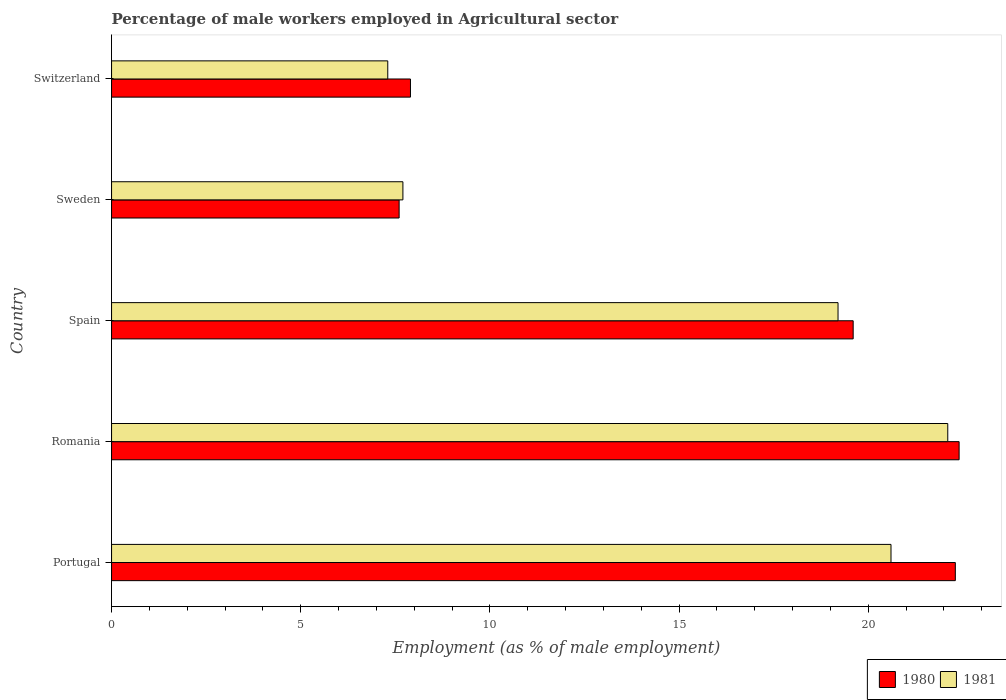How many different coloured bars are there?
Your answer should be compact. 2. How many groups of bars are there?
Provide a short and direct response. 5. Are the number of bars on each tick of the Y-axis equal?
Your answer should be compact. Yes. In how many cases, is the number of bars for a given country not equal to the number of legend labels?
Offer a very short reply. 0. What is the percentage of male workers employed in Agricultural sector in 1980 in Spain?
Provide a short and direct response. 19.6. Across all countries, what is the maximum percentage of male workers employed in Agricultural sector in 1981?
Ensure brevity in your answer.  22.1. Across all countries, what is the minimum percentage of male workers employed in Agricultural sector in 1981?
Keep it short and to the point. 7.3. In which country was the percentage of male workers employed in Agricultural sector in 1980 maximum?
Provide a short and direct response. Romania. In which country was the percentage of male workers employed in Agricultural sector in 1981 minimum?
Your answer should be compact. Switzerland. What is the total percentage of male workers employed in Agricultural sector in 1981 in the graph?
Keep it short and to the point. 76.9. What is the difference between the percentage of male workers employed in Agricultural sector in 1980 in Portugal and that in Spain?
Offer a terse response. 2.7. What is the difference between the percentage of male workers employed in Agricultural sector in 1981 in Spain and the percentage of male workers employed in Agricultural sector in 1980 in Sweden?
Your answer should be compact. 11.6. What is the average percentage of male workers employed in Agricultural sector in 1981 per country?
Offer a terse response. 15.38. What is the difference between the percentage of male workers employed in Agricultural sector in 1980 and percentage of male workers employed in Agricultural sector in 1981 in Sweden?
Your answer should be very brief. -0.1. What is the ratio of the percentage of male workers employed in Agricultural sector in 1981 in Portugal to that in Romania?
Ensure brevity in your answer.  0.93. Is the difference between the percentage of male workers employed in Agricultural sector in 1980 in Portugal and Romania greater than the difference between the percentage of male workers employed in Agricultural sector in 1981 in Portugal and Romania?
Your answer should be very brief. Yes. What is the difference between the highest and the second highest percentage of male workers employed in Agricultural sector in 1981?
Make the answer very short. 1.5. What is the difference between the highest and the lowest percentage of male workers employed in Agricultural sector in 1980?
Your response must be concise. 14.8. Is the sum of the percentage of male workers employed in Agricultural sector in 1980 in Spain and Switzerland greater than the maximum percentage of male workers employed in Agricultural sector in 1981 across all countries?
Provide a succinct answer. Yes. Are all the bars in the graph horizontal?
Offer a terse response. Yes. What is the difference between two consecutive major ticks on the X-axis?
Provide a short and direct response. 5. Are the values on the major ticks of X-axis written in scientific E-notation?
Your answer should be compact. No. What is the title of the graph?
Your response must be concise. Percentage of male workers employed in Agricultural sector. What is the label or title of the X-axis?
Keep it short and to the point. Employment (as % of male employment). What is the Employment (as % of male employment) in 1980 in Portugal?
Give a very brief answer. 22.3. What is the Employment (as % of male employment) in 1981 in Portugal?
Give a very brief answer. 20.6. What is the Employment (as % of male employment) in 1980 in Romania?
Give a very brief answer. 22.4. What is the Employment (as % of male employment) of 1981 in Romania?
Provide a succinct answer. 22.1. What is the Employment (as % of male employment) in 1980 in Spain?
Provide a short and direct response. 19.6. What is the Employment (as % of male employment) in 1981 in Spain?
Give a very brief answer. 19.2. What is the Employment (as % of male employment) of 1980 in Sweden?
Provide a succinct answer. 7.6. What is the Employment (as % of male employment) of 1981 in Sweden?
Your response must be concise. 7.7. What is the Employment (as % of male employment) in 1980 in Switzerland?
Your response must be concise. 7.9. What is the Employment (as % of male employment) in 1981 in Switzerland?
Offer a very short reply. 7.3. Across all countries, what is the maximum Employment (as % of male employment) in 1980?
Give a very brief answer. 22.4. Across all countries, what is the maximum Employment (as % of male employment) of 1981?
Your answer should be compact. 22.1. Across all countries, what is the minimum Employment (as % of male employment) of 1980?
Ensure brevity in your answer.  7.6. Across all countries, what is the minimum Employment (as % of male employment) of 1981?
Offer a terse response. 7.3. What is the total Employment (as % of male employment) in 1980 in the graph?
Offer a very short reply. 79.8. What is the total Employment (as % of male employment) in 1981 in the graph?
Offer a very short reply. 76.9. What is the difference between the Employment (as % of male employment) of 1980 in Portugal and that in Romania?
Ensure brevity in your answer.  -0.1. What is the difference between the Employment (as % of male employment) of 1981 in Portugal and that in Romania?
Your response must be concise. -1.5. What is the difference between the Employment (as % of male employment) in 1981 in Portugal and that in Spain?
Your answer should be compact. 1.4. What is the difference between the Employment (as % of male employment) of 1980 in Romania and that in Switzerland?
Your answer should be compact. 14.5. What is the difference between the Employment (as % of male employment) of 1980 in Spain and that in Sweden?
Provide a short and direct response. 12. What is the difference between the Employment (as % of male employment) in 1981 in Spain and that in Sweden?
Give a very brief answer. 11.5. What is the difference between the Employment (as % of male employment) in 1980 in Spain and that in Switzerland?
Your answer should be very brief. 11.7. What is the difference between the Employment (as % of male employment) of 1980 in Sweden and that in Switzerland?
Provide a short and direct response. -0.3. What is the difference between the Employment (as % of male employment) of 1981 in Sweden and that in Switzerland?
Your answer should be very brief. 0.4. What is the difference between the Employment (as % of male employment) in 1980 in Portugal and the Employment (as % of male employment) in 1981 in Romania?
Offer a very short reply. 0.2. What is the difference between the Employment (as % of male employment) in 1980 in Portugal and the Employment (as % of male employment) in 1981 in Spain?
Your answer should be compact. 3.1. What is the difference between the Employment (as % of male employment) in 1980 in Portugal and the Employment (as % of male employment) in 1981 in Switzerland?
Provide a succinct answer. 15. What is the difference between the Employment (as % of male employment) of 1980 in Romania and the Employment (as % of male employment) of 1981 in Spain?
Ensure brevity in your answer.  3.2. What is the difference between the Employment (as % of male employment) of 1980 in Romania and the Employment (as % of male employment) of 1981 in Sweden?
Offer a very short reply. 14.7. What is the average Employment (as % of male employment) of 1980 per country?
Provide a succinct answer. 15.96. What is the average Employment (as % of male employment) in 1981 per country?
Give a very brief answer. 15.38. What is the difference between the Employment (as % of male employment) in 1980 and Employment (as % of male employment) in 1981 in Romania?
Ensure brevity in your answer.  0.3. What is the difference between the Employment (as % of male employment) of 1980 and Employment (as % of male employment) of 1981 in Sweden?
Keep it short and to the point. -0.1. What is the ratio of the Employment (as % of male employment) in 1981 in Portugal to that in Romania?
Offer a terse response. 0.93. What is the ratio of the Employment (as % of male employment) in 1980 in Portugal to that in Spain?
Offer a very short reply. 1.14. What is the ratio of the Employment (as % of male employment) in 1981 in Portugal to that in Spain?
Offer a very short reply. 1.07. What is the ratio of the Employment (as % of male employment) in 1980 in Portugal to that in Sweden?
Your response must be concise. 2.93. What is the ratio of the Employment (as % of male employment) in 1981 in Portugal to that in Sweden?
Give a very brief answer. 2.68. What is the ratio of the Employment (as % of male employment) in 1980 in Portugal to that in Switzerland?
Keep it short and to the point. 2.82. What is the ratio of the Employment (as % of male employment) in 1981 in Portugal to that in Switzerland?
Ensure brevity in your answer.  2.82. What is the ratio of the Employment (as % of male employment) of 1980 in Romania to that in Spain?
Your response must be concise. 1.14. What is the ratio of the Employment (as % of male employment) in 1981 in Romania to that in Spain?
Make the answer very short. 1.15. What is the ratio of the Employment (as % of male employment) of 1980 in Romania to that in Sweden?
Your answer should be compact. 2.95. What is the ratio of the Employment (as % of male employment) in 1981 in Romania to that in Sweden?
Provide a short and direct response. 2.87. What is the ratio of the Employment (as % of male employment) in 1980 in Romania to that in Switzerland?
Give a very brief answer. 2.84. What is the ratio of the Employment (as % of male employment) of 1981 in Romania to that in Switzerland?
Give a very brief answer. 3.03. What is the ratio of the Employment (as % of male employment) in 1980 in Spain to that in Sweden?
Give a very brief answer. 2.58. What is the ratio of the Employment (as % of male employment) in 1981 in Spain to that in Sweden?
Give a very brief answer. 2.49. What is the ratio of the Employment (as % of male employment) in 1980 in Spain to that in Switzerland?
Offer a very short reply. 2.48. What is the ratio of the Employment (as % of male employment) in 1981 in Spain to that in Switzerland?
Keep it short and to the point. 2.63. What is the ratio of the Employment (as % of male employment) in 1981 in Sweden to that in Switzerland?
Offer a terse response. 1.05. What is the difference between the highest and the second highest Employment (as % of male employment) in 1980?
Provide a succinct answer. 0.1. 